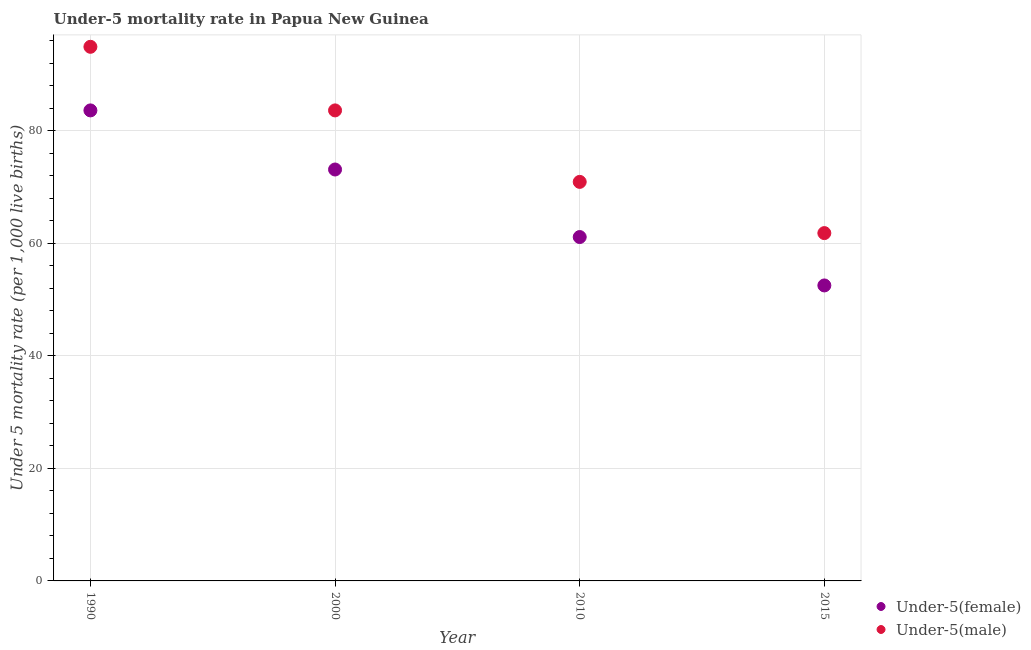How many different coloured dotlines are there?
Offer a terse response. 2. Is the number of dotlines equal to the number of legend labels?
Offer a very short reply. Yes. What is the under-5 female mortality rate in 1990?
Offer a terse response. 83.6. Across all years, what is the maximum under-5 male mortality rate?
Your response must be concise. 94.9. Across all years, what is the minimum under-5 male mortality rate?
Your answer should be compact. 61.8. In which year was the under-5 male mortality rate maximum?
Make the answer very short. 1990. In which year was the under-5 male mortality rate minimum?
Your response must be concise. 2015. What is the total under-5 female mortality rate in the graph?
Your answer should be compact. 270.3. What is the difference between the under-5 male mortality rate in 2010 and that in 2015?
Provide a succinct answer. 9.1. What is the difference between the under-5 male mortality rate in 2010 and the under-5 female mortality rate in 2015?
Give a very brief answer. 18.4. What is the average under-5 female mortality rate per year?
Offer a very short reply. 67.57. In the year 1990, what is the difference between the under-5 female mortality rate and under-5 male mortality rate?
Offer a very short reply. -11.3. In how many years, is the under-5 female mortality rate greater than 68?
Give a very brief answer. 2. What is the ratio of the under-5 female mortality rate in 2010 to that in 2015?
Provide a succinct answer. 1.16. What is the difference between the highest and the second highest under-5 male mortality rate?
Offer a terse response. 11.3. What is the difference between the highest and the lowest under-5 male mortality rate?
Offer a very short reply. 33.1. In how many years, is the under-5 female mortality rate greater than the average under-5 female mortality rate taken over all years?
Keep it short and to the point. 2. Is the sum of the under-5 male mortality rate in 2000 and 2010 greater than the maximum under-5 female mortality rate across all years?
Make the answer very short. Yes. Does the under-5 female mortality rate monotonically increase over the years?
Provide a short and direct response. No. Is the under-5 male mortality rate strictly less than the under-5 female mortality rate over the years?
Make the answer very short. No. How many years are there in the graph?
Your answer should be compact. 4. Where does the legend appear in the graph?
Give a very brief answer. Bottom right. How are the legend labels stacked?
Keep it short and to the point. Vertical. What is the title of the graph?
Give a very brief answer. Under-5 mortality rate in Papua New Guinea. Does "Formally registered" appear as one of the legend labels in the graph?
Your answer should be compact. No. What is the label or title of the Y-axis?
Your answer should be very brief. Under 5 mortality rate (per 1,0 live births). What is the Under 5 mortality rate (per 1,000 live births) of Under-5(female) in 1990?
Your answer should be compact. 83.6. What is the Under 5 mortality rate (per 1,000 live births) in Under-5(male) in 1990?
Provide a short and direct response. 94.9. What is the Under 5 mortality rate (per 1,000 live births) of Under-5(female) in 2000?
Ensure brevity in your answer.  73.1. What is the Under 5 mortality rate (per 1,000 live births) of Under-5(male) in 2000?
Offer a very short reply. 83.6. What is the Under 5 mortality rate (per 1,000 live births) in Under-5(female) in 2010?
Provide a succinct answer. 61.1. What is the Under 5 mortality rate (per 1,000 live births) of Under-5(male) in 2010?
Your answer should be very brief. 70.9. What is the Under 5 mortality rate (per 1,000 live births) in Under-5(female) in 2015?
Ensure brevity in your answer.  52.5. What is the Under 5 mortality rate (per 1,000 live births) of Under-5(male) in 2015?
Provide a succinct answer. 61.8. Across all years, what is the maximum Under 5 mortality rate (per 1,000 live births) of Under-5(female)?
Make the answer very short. 83.6. Across all years, what is the maximum Under 5 mortality rate (per 1,000 live births) of Under-5(male)?
Ensure brevity in your answer.  94.9. Across all years, what is the minimum Under 5 mortality rate (per 1,000 live births) in Under-5(female)?
Offer a terse response. 52.5. Across all years, what is the minimum Under 5 mortality rate (per 1,000 live births) of Under-5(male)?
Your answer should be compact. 61.8. What is the total Under 5 mortality rate (per 1,000 live births) in Under-5(female) in the graph?
Offer a terse response. 270.3. What is the total Under 5 mortality rate (per 1,000 live births) of Under-5(male) in the graph?
Provide a succinct answer. 311.2. What is the difference between the Under 5 mortality rate (per 1,000 live births) in Under-5(female) in 1990 and that in 2000?
Give a very brief answer. 10.5. What is the difference between the Under 5 mortality rate (per 1,000 live births) in Under-5(male) in 1990 and that in 2000?
Keep it short and to the point. 11.3. What is the difference between the Under 5 mortality rate (per 1,000 live births) of Under-5(female) in 1990 and that in 2010?
Offer a very short reply. 22.5. What is the difference between the Under 5 mortality rate (per 1,000 live births) in Under-5(female) in 1990 and that in 2015?
Ensure brevity in your answer.  31.1. What is the difference between the Under 5 mortality rate (per 1,000 live births) in Under-5(male) in 1990 and that in 2015?
Keep it short and to the point. 33.1. What is the difference between the Under 5 mortality rate (per 1,000 live births) in Under-5(female) in 2000 and that in 2010?
Keep it short and to the point. 12. What is the difference between the Under 5 mortality rate (per 1,000 live births) in Under-5(female) in 2000 and that in 2015?
Ensure brevity in your answer.  20.6. What is the difference between the Under 5 mortality rate (per 1,000 live births) in Under-5(male) in 2000 and that in 2015?
Keep it short and to the point. 21.8. What is the difference between the Under 5 mortality rate (per 1,000 live births) in Under-5(female) in 2010 and that in 2015?
Your answer should be compact. 8.6. What is the difference between the Under 5 mortality rate (per 1,000 live births) of Under-5(male) in 2010 and that in 2015?
Keep it short and to the point. 9.1. What is the difference between the Under 5 mortality rate (per 1,000 live births) of Under-5(female) in 1990 and the Under 5 mortality rate (per 1,000 live births) of Under-5(male) in 2000?
Keep it short and to the point. 0. What is the difference between the Under 5 mortality rate (per 1,000 live births) in Under-5(female) in 1990 and the Under 5 mortality rate (per 1,000 live births) in Under-5(male) in 2015?
Your response must be concise. 21.8. What is the difference between the Under 5 mortality rate (per 1,000 live births) in Under-5(female) in 2000 and the Under 5 mortality rate (per 1,000 live births) in Under-5(male) in 2015?
Provide a short and direct response. 11.3. What is the difference between the Under 5 mortality rate (per 1,000 live births) of Under-5(female) in 2010 and the Under 5 mortality rate (per 1,000 live births) of Under-5(male) in 2015?
Provide a short and direct response. -0.7. What is the average Under 5 mortality rate (per 1,000 live births) in Under-5(female) per year?
Make the answer very short. 67.58. What is the average Under 5 mortality rate (per 1,000 live births) in Under-5(male) per year?
Keep it short and to the point. 77.8. In the year 2010, what is the difference between the Under 5 mortality rate (per 1,000 live births) of Under-5(female) and Under 5 mortality rate (per 1,000 live births) of Under-5(male)?
Offer a very short reply. -9.8. What is the ratio of the Under 5 mortality rate (per 1,000 live births) of Under-5(female) in 1990 to that in 2000?
Offer a terse response. 1.14. What is the ratio of the Under 5 mortality rate (per 1,000 live births) in Under-5(male) in 1990 to that in 2000?
Give a very brief answer. 1.14. What is the ratio of the Under 5 mortality rate (per 1,000 live births) of Under-5(female) in 1990 to that in 2010?
Offer a very short reply. 1.37. What is the ratio of the Under 5 mortality rate (per 1,000 live births) in Under-5(male) in 1990 to that in 2010?
Your answer should be compact. 1.34. What is the ratio of the Under 5 mortality rate (per 1,000 live births) in Under-5(female) in 1990 to that in 2015?
Keep it short and to the point. 1.59. What is the ratio of the Under 5 mortality rate (per 1,000 live births) of Under-5(male) in 1990 to that in 2015?
Your response must be concise. 1.54. What is the ratio of the Under 5 mortality rate (per 1,000 live births) of Under-5(female) in 2000 to that in 2010?
Keep it short and to the point. 1.2. What is the ratio of the Under 5 mortality rate (per 1,000 live births) in Under-5(male) in 2000 to that in 2010?
Offer a very short reply. 1.18. What is the ratio of the Under 5 mortality rate (per 1,000 live births) of Under-5(female) in 2000 to that in 2015?
Make the answer very short. 1.39. What is the ratio of the Under 5 mortality rate (per 1,000 live births) of Under-5(male) in 2000 to that in 2015?
Keep it short and to the point. 1.35. What is the ratio of the Under 5 mortality rate (per 1,000 live births) of Under-5(female) in 2010 to that in 2015?
Offer a very short reply. 1.16. What is the ratio of the Under 5 mortality rate (per 1,000 live births) in Under-5(male) in 2010 to that in 2015?
Provide a succinct answer. 1.15. What is the difference between the highest and the second highest Under 5 mortality rate (per 1,000 live births) of Under-5(female)?
Your answer should be compact. 10.5. What is the difference between the highest and the second highest Under 5 mortality rate (per 1,000 live births) in Under-5(male)?
Your answer should be very brief. 11.3. What is the difference between the highest and the lowest Under 5 mortality rate (per 1,000 live births) in Under-5(female)?
Ensure brevity in your answer.  31.1. What is the difference between the highest and the lowest Under 5 mortality rate (per 1,000 live births) in Under-5(male)?
Offer a terse response. 33.1. 